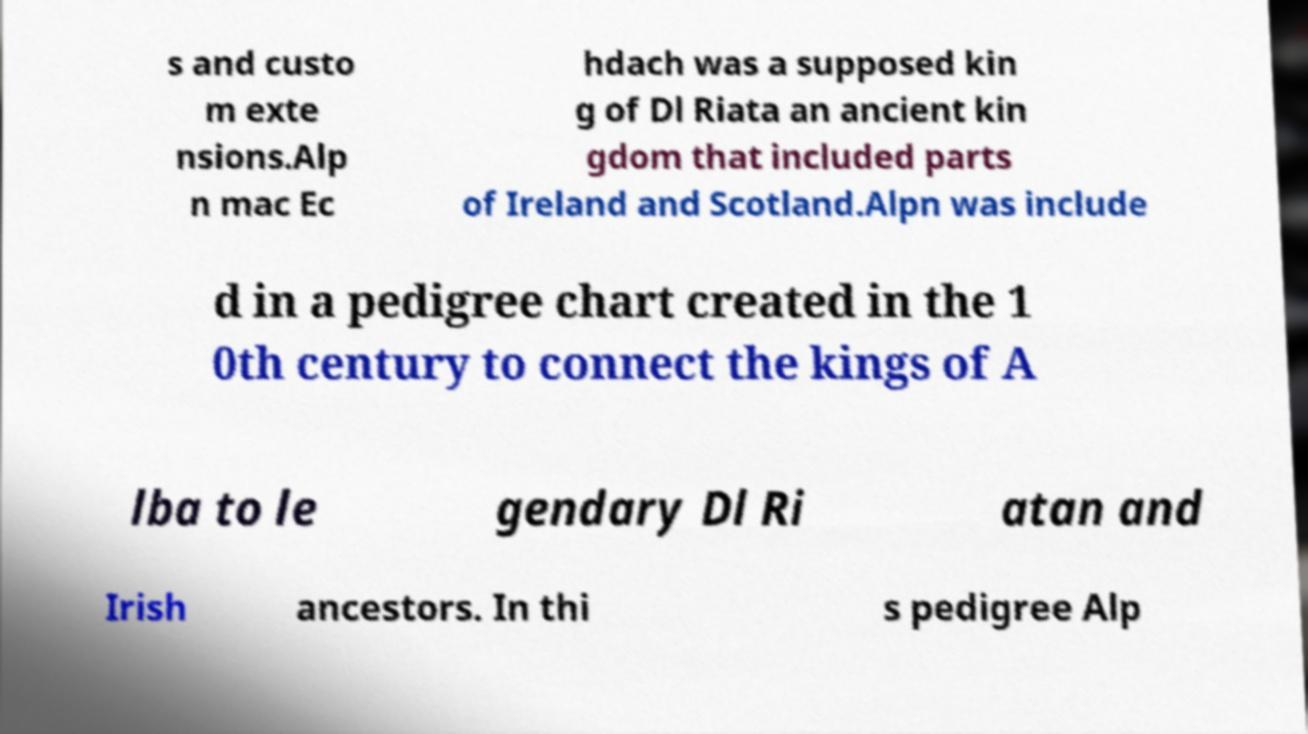Please identify and transcribe the text found in this image. s and custo m exte nsions.Alp n mac Ec hdach was a supposed kin g of Dl Riata an ancient kin gdom that included parts of Ireland and Scotland.Alpn was include d in a pedigree chart created in the 1 0th century to connect the kings of A lba to le gendary Dl Ri atan and Irish ancestors. In thi s pedigree Alp 